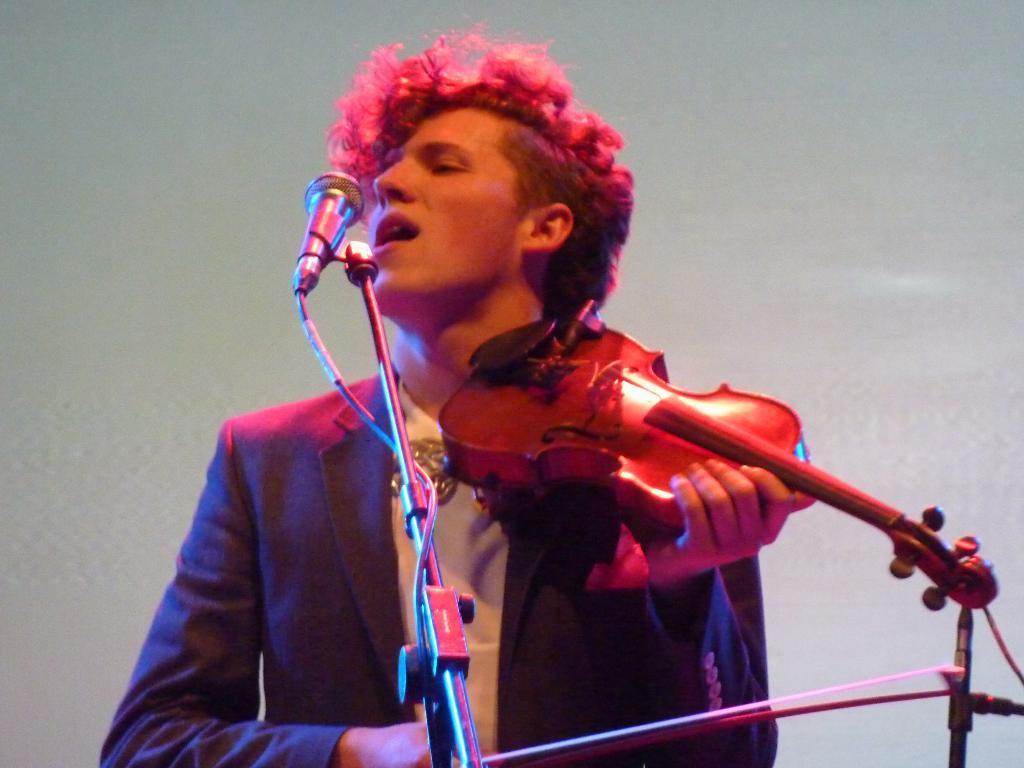In one or two sentences, can you explain what this image depicts? In this image we can see a man. He is wearing a suit and playing guitar. In front of him, stand and mic is present. The background is white in color. 